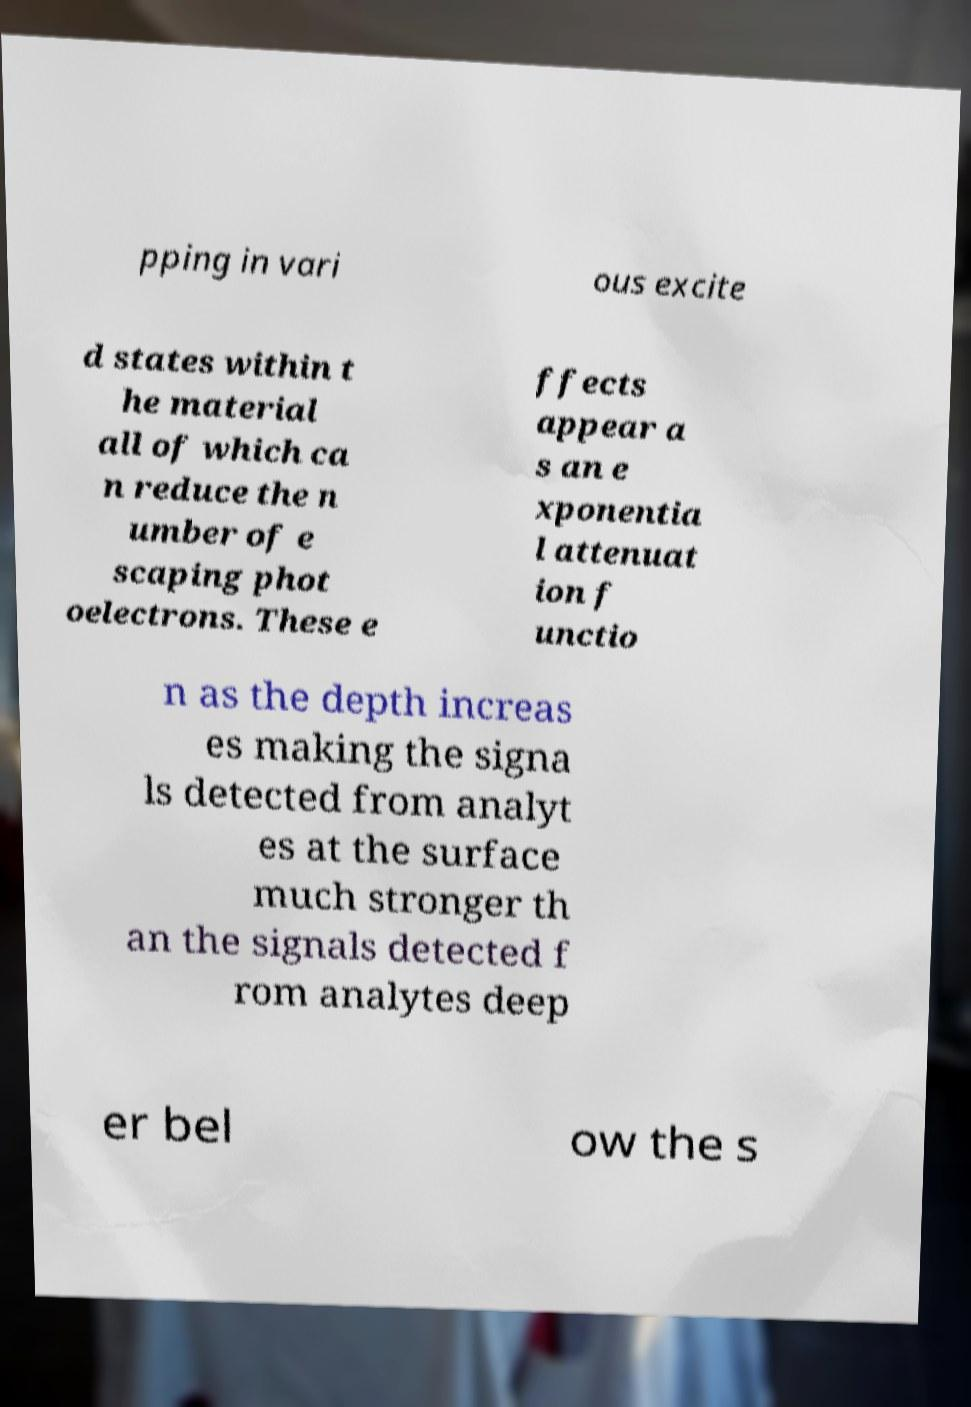Please identify and transcribe the text found in this image. pping in vari ous excite d states within t he material all of which ca n reduce the n umber of e scaping phot oelectrons. These e ffects appear a s an e xponentia l attenuat ion f unctio n as the depth increas es making the signa ls detected from analyt es at the surface much stronger th an the signals detected f rom analytes deep er bel ow the s 